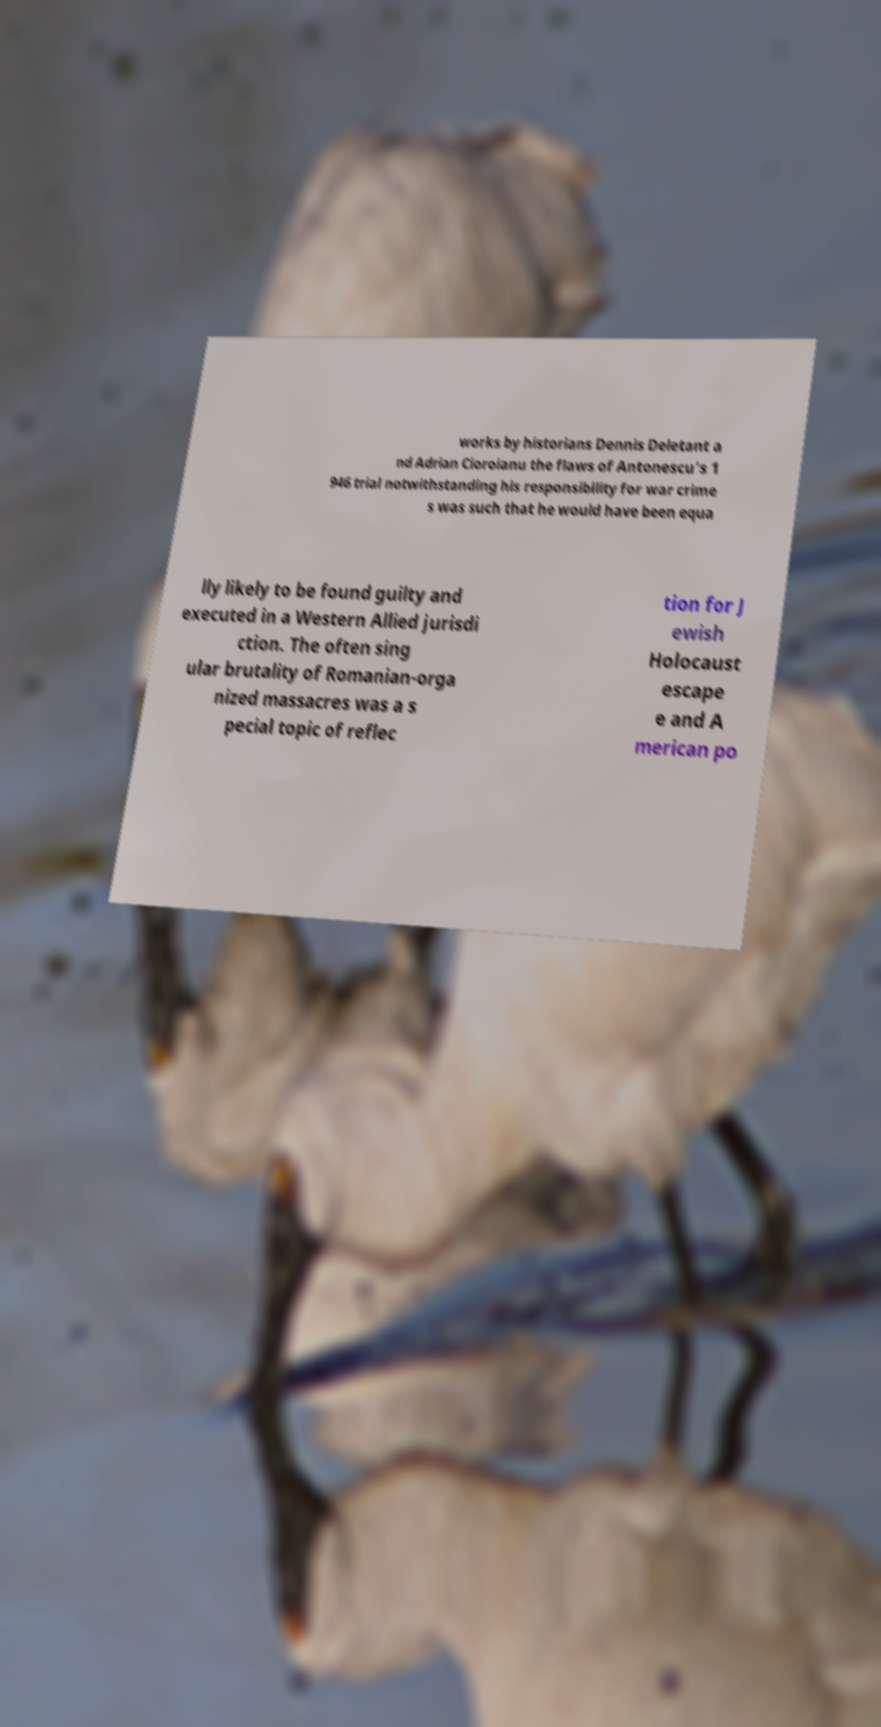Could you extract and type out the text from this image? works by historians Dennis Deletant a nd Adrian Cioroianu the flaws of Antonescu's 1 946 trial notwithstanding his responsibility for war crime s was such that he would have been equa lly likely to be found guilty and executed in a Western Allied jurisdi ction. The often sing ular brutality of Romanian-orga nized massacres was a s pecial topic of reflec tion for J ewish Holocaust escape e and A merican po 